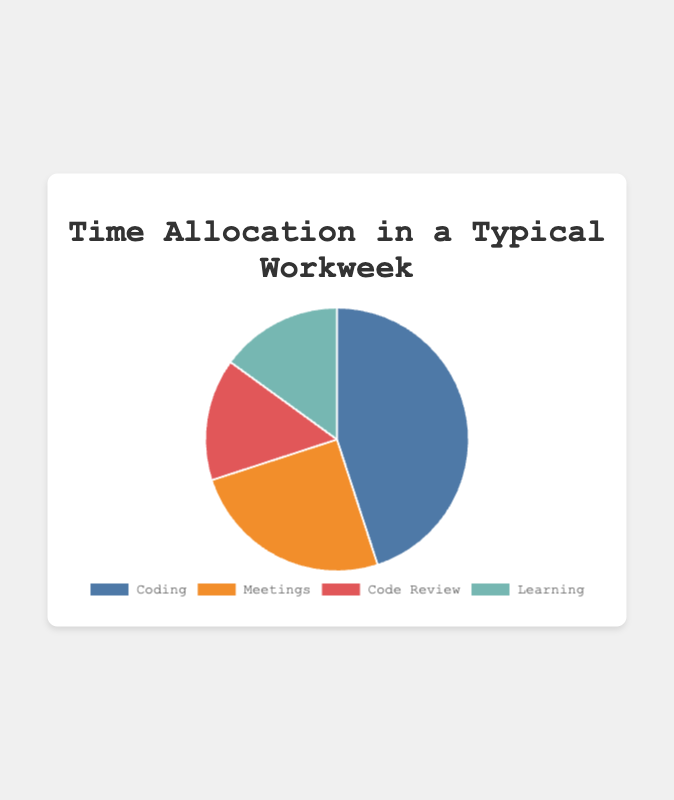Which activity takes up the largest portion of the workweek? The pie chart shows each activity's portion of the workweek. Coding has the largest portion.
Answer: Coding Which two activities together take up as much time as Coding? From the pie chart, we see that Coding takes 45%. Meetings take 25% and Code Review takes 15%, which together make 25% + 15% = 40%, close but not equal. However, Meetings and Learning together take 25% + 15% = 40%, still shorter. Thus, Meetings and Code Review or Meetings and Learning together do not equal 45%. The closest match is Meetings and Learning together.
Answer: Meetings and Learning What is the difference in percentage between the time spent on Coding and Meetings? The pie chart shows that Coding takes 45% and Meetings take 25%. The difference is 45% - 25%.
Answer: 20% What percentage of time is spent on Code Review? The pie chart shows that Code Review takes up 15%.
Answer: 15% How much more time is allocated to Coding compared to Learning? From the pie chart, Coding takes 45%, and Learning takes 15%. The difference is 45% - 15%.
Answer: 30% What is the combined percentage of time spent on Code Review and Learning? The pie chart shows Code Review at 15% and Learning at 15%. Adding these gives 15% + 15%.
Answer: 30% How do the percentages for Coding and Code Review compare visually? Coding has a noticeably larger segment than Code Review.
Answer: Coding segment is larger Which activity segment is the smallest? The pie chart shows that Code Review and Learning both take the smallest, equal portions of 15%.
Answer: Code Review or Learning Based on the pie chart, how does the time spent on Meetings compare to the time spent on Learning? Meetings take 25%, while Learning takes 15%. So, Meetings take up 10% more time than Learning.
Answer: 10% more 